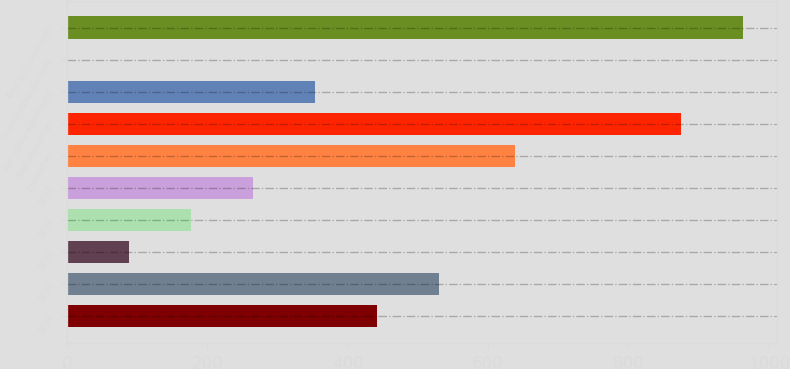Convert chart to OTSL. <chart><loc_0><loc_0><loc_500><loc_500><bar_chart><fcel>2009<fcel>2010<fcel>2011<fcel>2012<fcel>2013<fcel>Thereafter<fcel>Total maturities<fcel>Fair value adjustment<fcel>Unamortized discount<fcel>Total long-term debt<nl><fcel>442<fcel>530.2<fcel>89.2<fcel>177.4<fcel>265.6<fcel>639<fcel>875<fcel>353.8<fcel>1<fcel>963.2<nl></chart> 